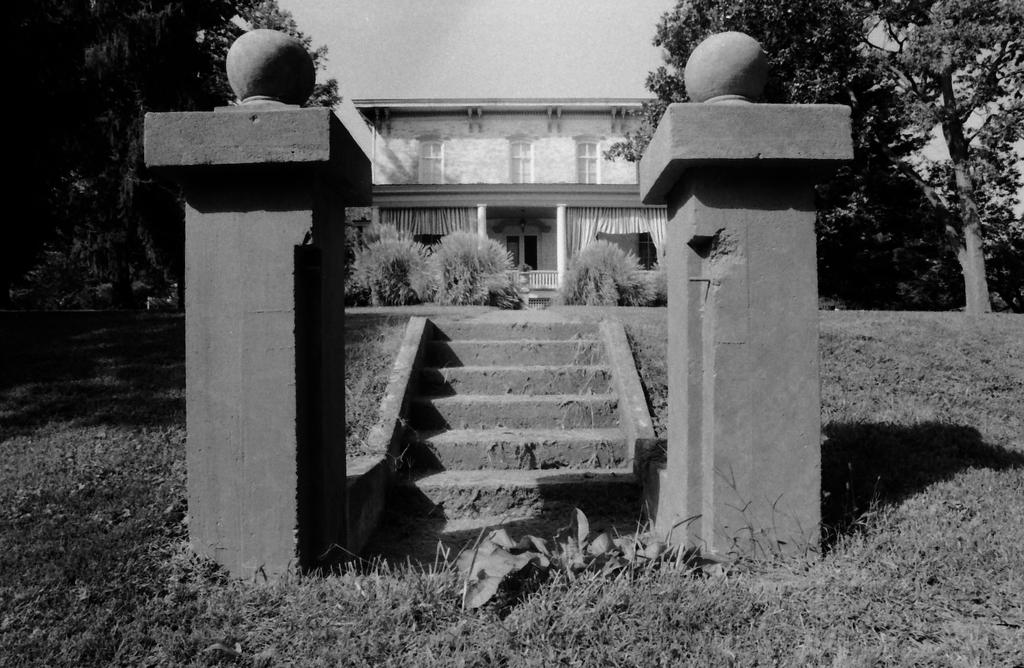What is the color scheme of the image? The image is black and white. What architectural feature can be seen in the image? There are stairs in the image. What type of building is depicted in the image? There is a house with windows in the image. What natural elements are present in the image? Trees, bushes, and grass are visible in the image. What structural elements can be seen in the image? There are pillars in the image. What scientific discovery is being celebrated in the image? There is no indication of a scientific discovery or celebration in the image. What level of agreement is depicted in the image? The image does not show any agreement or disagreement between individuals or entities. 